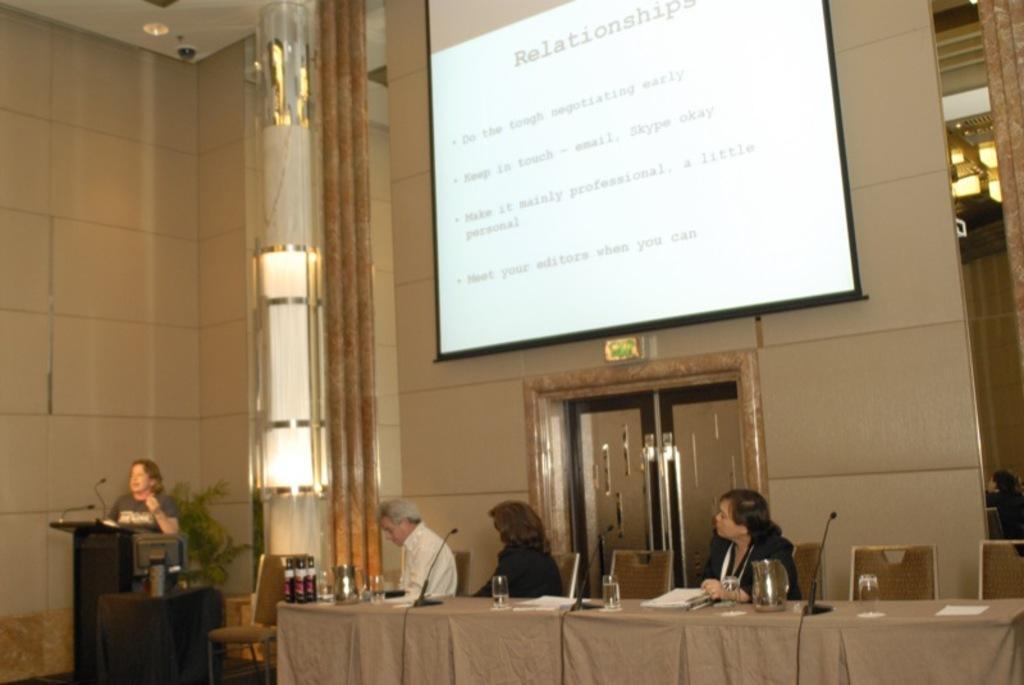How would you summarize this image in a sentence or two? In this image there is a person standing on the dais and speaking in front of the mic, beside the person there are a few people seated on chairs, in front of them on the table there are papers, mic's and glasses of water, behind them on the wall there is a big screen. 